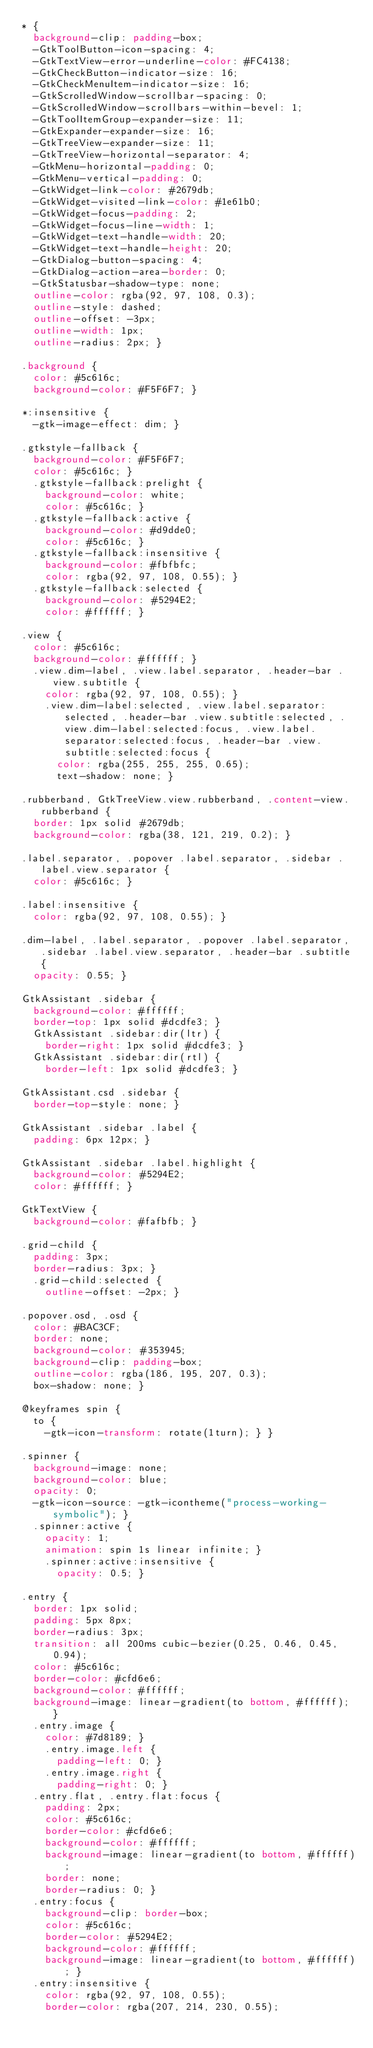<code> <loc_0><loc_0><loc_500><loc_500><_CSS_>* {
  background-clip: padding-box;
  -GtkToolButton-icon-spacing: 4;
  -GtkTextView-error-underline-color: #FC4138;
  -GtkCheckButton-indicator-size: 16;
  -GtkCheckMenuItem-indicator-size: 16;
  -GtkScrolledWindow-scrollbar-spacing: 0;
  -GtkScrolledWindow-scrollbars-within-bevel: 1;
  -GtkToolItemGroup-expander-size: 11;
  -GtkExpander-expander-size: 16;
  -GtkTreeView-expander-size: 11;
  -GtkTreeView-horizontal-separator: 4;
  -GtkMenu-horizontal-padding: 0;
  -GtkMenu-vertical-padding: 0;
  -GtkWidget-link-color: #2679db;
  -GtkWidget-visited-link-color: #1e61b0;
  -GtkWidget-focus-padding: 2;
  -GtkWidget-focus-line-width: 1;
  -GtkWidget-text-handle-width: 20;
  -GtkWidget-text-handle-height: 20;
  -GtkDialog-button-spacing: 4;
  -GtkDialog-action-area-border: 0;
  -GtkStatusbar-shadow-type: none;
  outline-color: rgba(92, 97, 108, 0.3);
  outline-style: dashed;
  outline-offset: -3px;
  outline-width: 1px;
  outline-radius: 2px; }

.background {
  color: #5c616c;
  background-color: #F5F6F7; }

*:insensitive {
  -gtk-image-effect: dim; }

.gtkstyle-fallback {
  background-color: #F5F6F7;
  color: #5c616c; }
  .gtkstyle-fallback:prelight {
    background-color: white;
    color: #5c616c; }
  .gtkstyle-fallback:active {
    background-color: #d9dde0;
    color: #5c616c; }
  .gtkstyle-fallback:insensitive {
    background-color: #fbfbfc;
    color: rgba(92, 97, 108, 0.55); }
  .gtkstyle-fallback:selected {
    background-color: #5294E2;
    color: #ffffff; }

.view {
  color: #5c616c;
  background-color: #ffffff; }
  .view.dim-label, .view.label.separator, .header-bar .view.subtitle {
    color: rgba(92, 97, 108, 0.55); }
    .view.dim-label:selected, .view.label.separator:selected, .header-bar .view.subtitle:selected, .view.dim-label:selected:focus, .view.label.separator:selected:focus, .header-bar .view.subtitle:selected:focus {
      color: rgba(255, 255, 255, 0.65);
      text-shadow: none; }

.rubberband, GtkTreeView.view.rubberband, .content-view.rubberband {
  border: 1px solid #2679db;
  background-color: rgba(38, 121, 219, 0.2); }

.label.separator, .popover .label.separator, .sidebar .label.view.separator {
  color: #5c616c; }

.label:insensitive {
  color: rgba(92, 97, 108, 0.55); }

.dim-label, .label.separator, .popover .label.separator, .sidebar .label.view.separator, .header-bar .subtitle {
  opacity: 0.55; }

GtkAssistant .sidebar {
  background-color: #ffffff;
  border-top: 1px solid #dcdfe3; }
  GtkAssistant .sidebar:dir(ltr) {
    border-right: 1px solid #dcdfe3; }
  GtkAssistant .sidebar:dir(rtl) {
    border-left: 1px solid #dcdfe3; }

GtkAssistant.csd .sidebar {
  border-top-style: none; }

GtkAssistant .sidebar .label {
  padding: 6px 12px; }

GtkAssistant .sidebar .label.highlight {
  background-color: #5294E2;
  color: #ffffff; }

GtkTextView {
  background-color: #fafbfb; }

.grid-child {
  padding: 3px;
  border-radius: 3px; }
  .grid-child:selected {
    outline-offset: -2px; }

.popover.osd, .osd {
  color: #BAC3CF;
  border: none;
  background-color: #353945;
  background-clip: padding-box;
  outline-color: rgba(186, 195, 207, 0.3);
  box-shadow: none; }

@keyframes spin {
  to {
    -gtk-icon-transform: rotate(1turn); } }

.spinner {
  background-image: none;
  background-color: blue;
  opacity: 0;
  -gtk-icon-source: -gtk-icontheme("process-working-symbolic"); }
  .spinner:active {
    opacity: 1;
    animation: spin 1s linear infinite; }
    .spinner:active:insensitive {
      opacity: 0.5; }

.entry {
  border: 1px solid;
  padding: 5px 8px;
  border-radius: 3px;
  transition: all 200ms cubic-bezier(0.25, 0.46, 0.45, 0.94);
  color: #5c616c;
  border-color: #cfd6e6;
  background-color: #ffffff;
  background-image: linear-gradient(to bottom, #ffffff); }
  .entry.image {
    color: #7d8189; }
    .entry.image.left {
      padding-left: 0; }
    .entry.image.right {
      padding-right: 0; }
  .entry.flat, .entry.flat:focus {
    padding: 2px;
    color: #5c616c;
    border-color: #cfd6e6;
    background-color: #ffffff;
    background-image: linear-gradient(to bottom, #ffffff);
    border: none;
    border-radius: 0; }
  .entry:focus {
    background-clip: border-box;
    color: #5c616c;
    border-color: #5294E2;
    background-color: #ffffff;
    background-image: linear-gradient(to bottom, #ffffff); }
  .entry:insensitive {
    color: rgba(92, 97, 108, 0.55);
    border-color: rgba(207, 214, 230, 0.55);</code> 